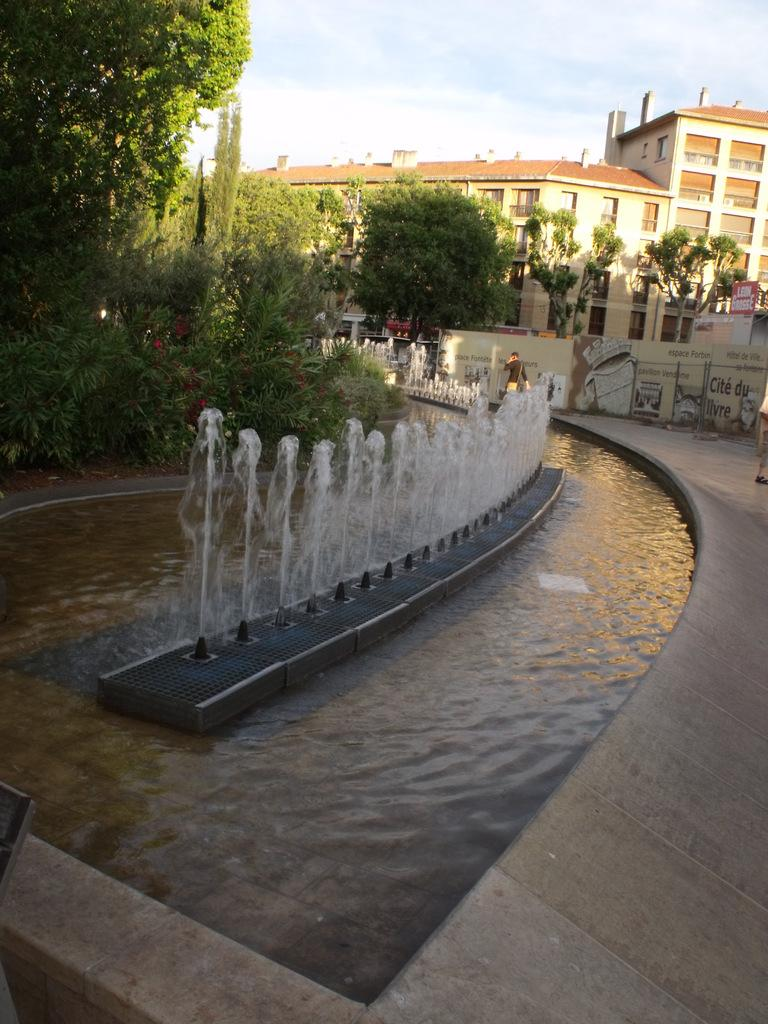What is the primary element visible in the image? There is water in the image. What types of vegetation can be seen in the image? There are plants and trees in the image. What man-made structures are present in the image? There are boards and a wall in the image. Who or what is present in the image? There is a person in the image. What can be seen in the background of the image? There are buildings and the sky visible in the background of the image. What type of tooth is being used to smash the train in the image? There is no tooth or train present in the image. 